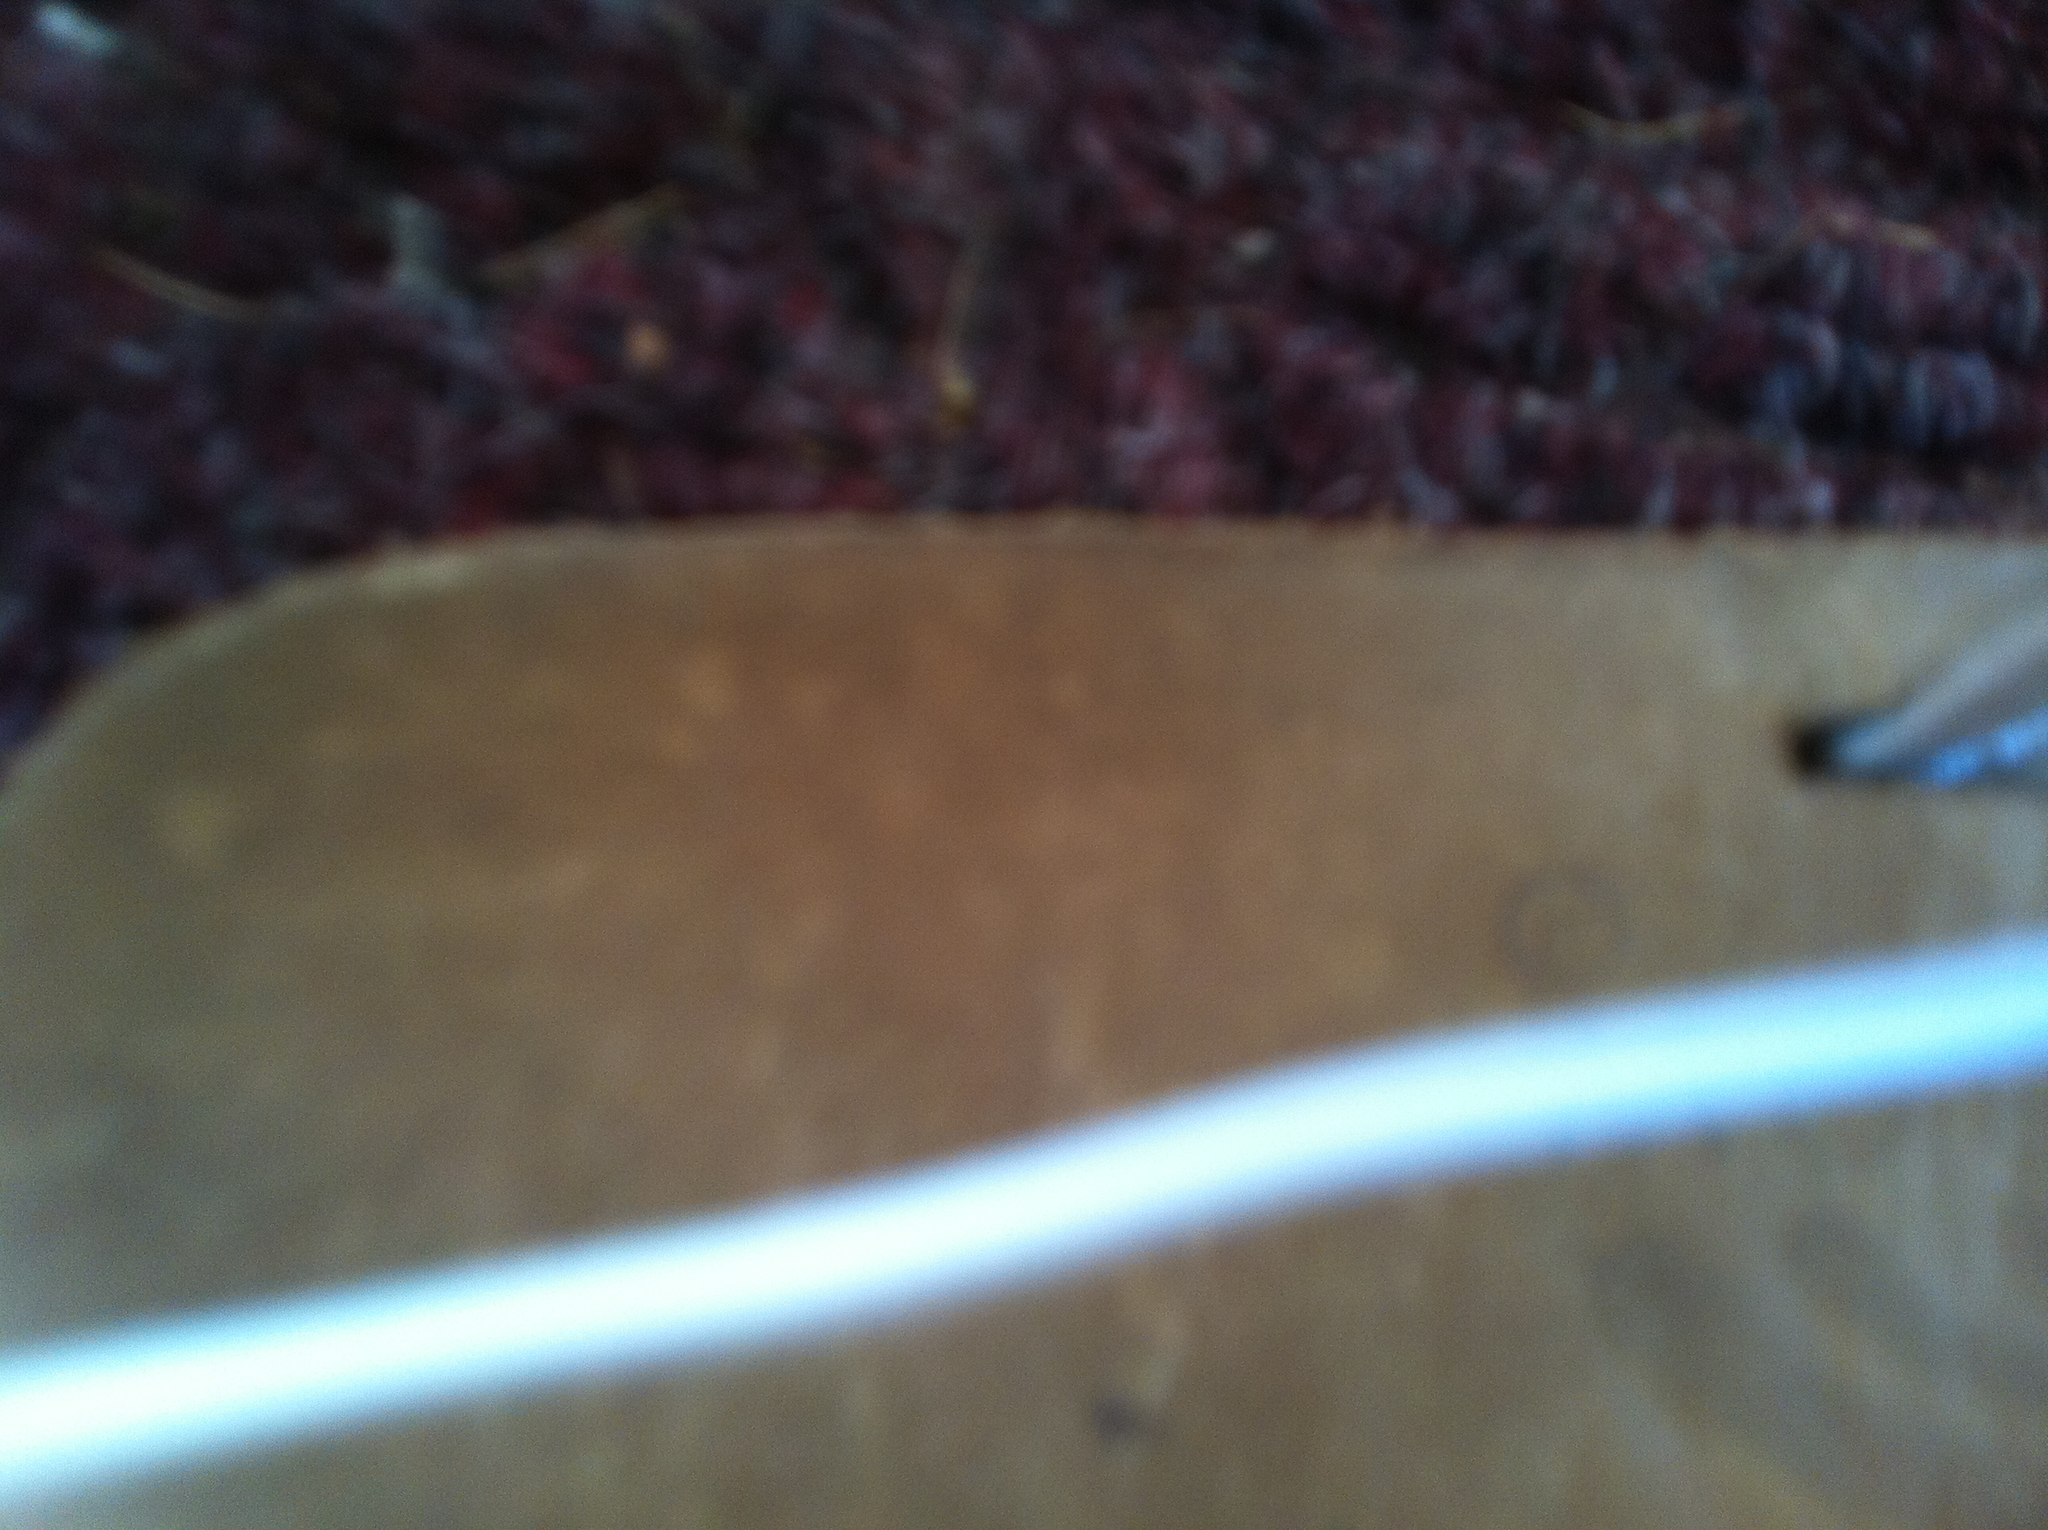Can you describe the texture of the shoe shown? It appears that the shoe has a smooth texture, possibly made of leather or a polished material. The blurred nature of the image limits the ability to determine this with certainty. What type of occasions would this shoe be suitable for? Given its smooth and polished appearance, this shoe seems suitable for formal events such as business meetings, weddings, or other professional settings. 